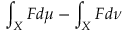<formula> <loc_0><loc_0><loc_500><loc_500>\int _ { X } F d \mu - \int _ { X } F d \nu</formula> 